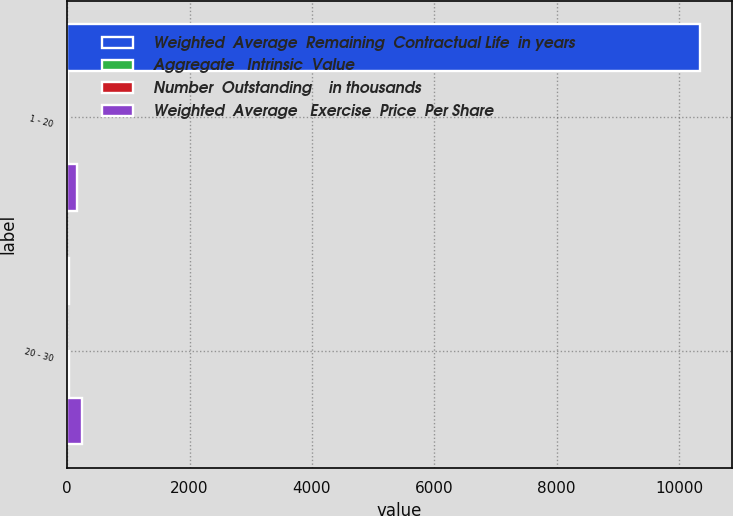Convert chart to OTSL. <chart><loc_0><loc_0><loc_500><loc_500><stacked_bar_chart><ecel><fcel>1 - 20<fcel>20 - 30<nl><fcel>Weighted  Average  Remaining  Contractual Life  in years<fcel>10344<fcel>25.06<nl><fcel>Aggregate   Intrinsic  Value<fcel>6.16<fcel>3<nl><fcel>Number  Outstanding    in thousands<fcel>17.51<fcel>25.06<nl><fcel>Weighted  Average   Exercise  Price  Per Share<fcel>156<fcel>238<nl></chart> 